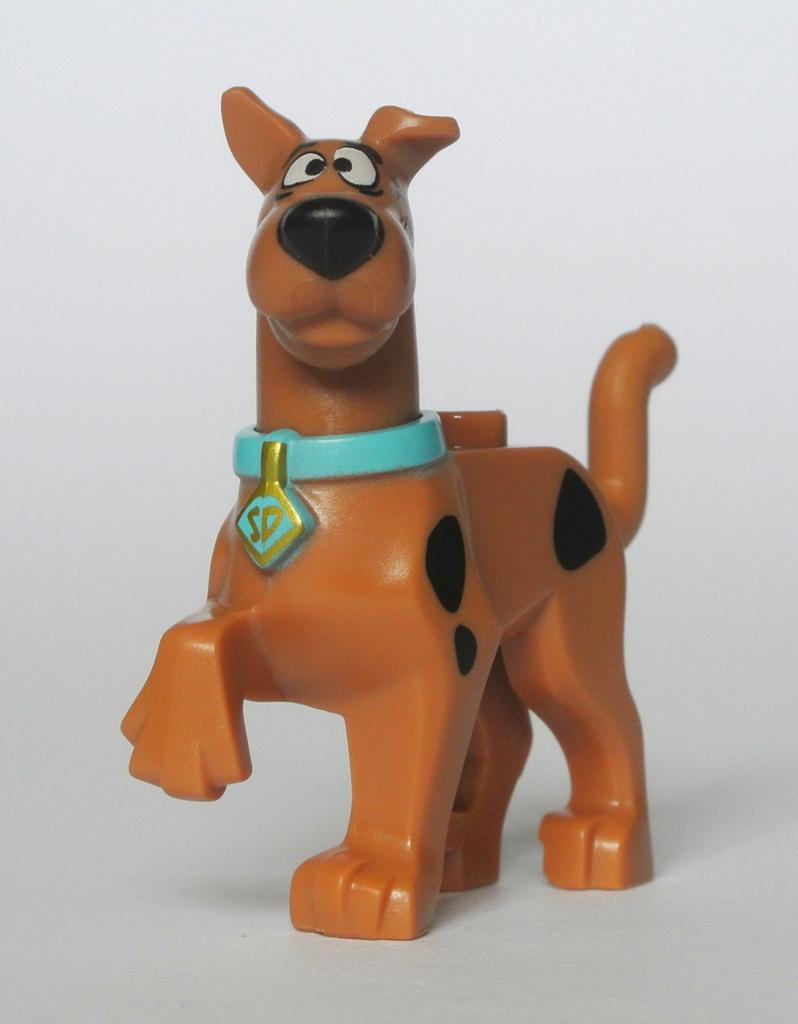What type of animal is in the picture? There is a dog in the picture. Can you describe the dog's appearance? The dog is brown and black in color. What is around the dog's neck? The dog has a blue color belt around its neck. How many cherries are on the pot in the image? There is no pot or cherries present in the image; it features a dog with a blue color belt around its neck. 